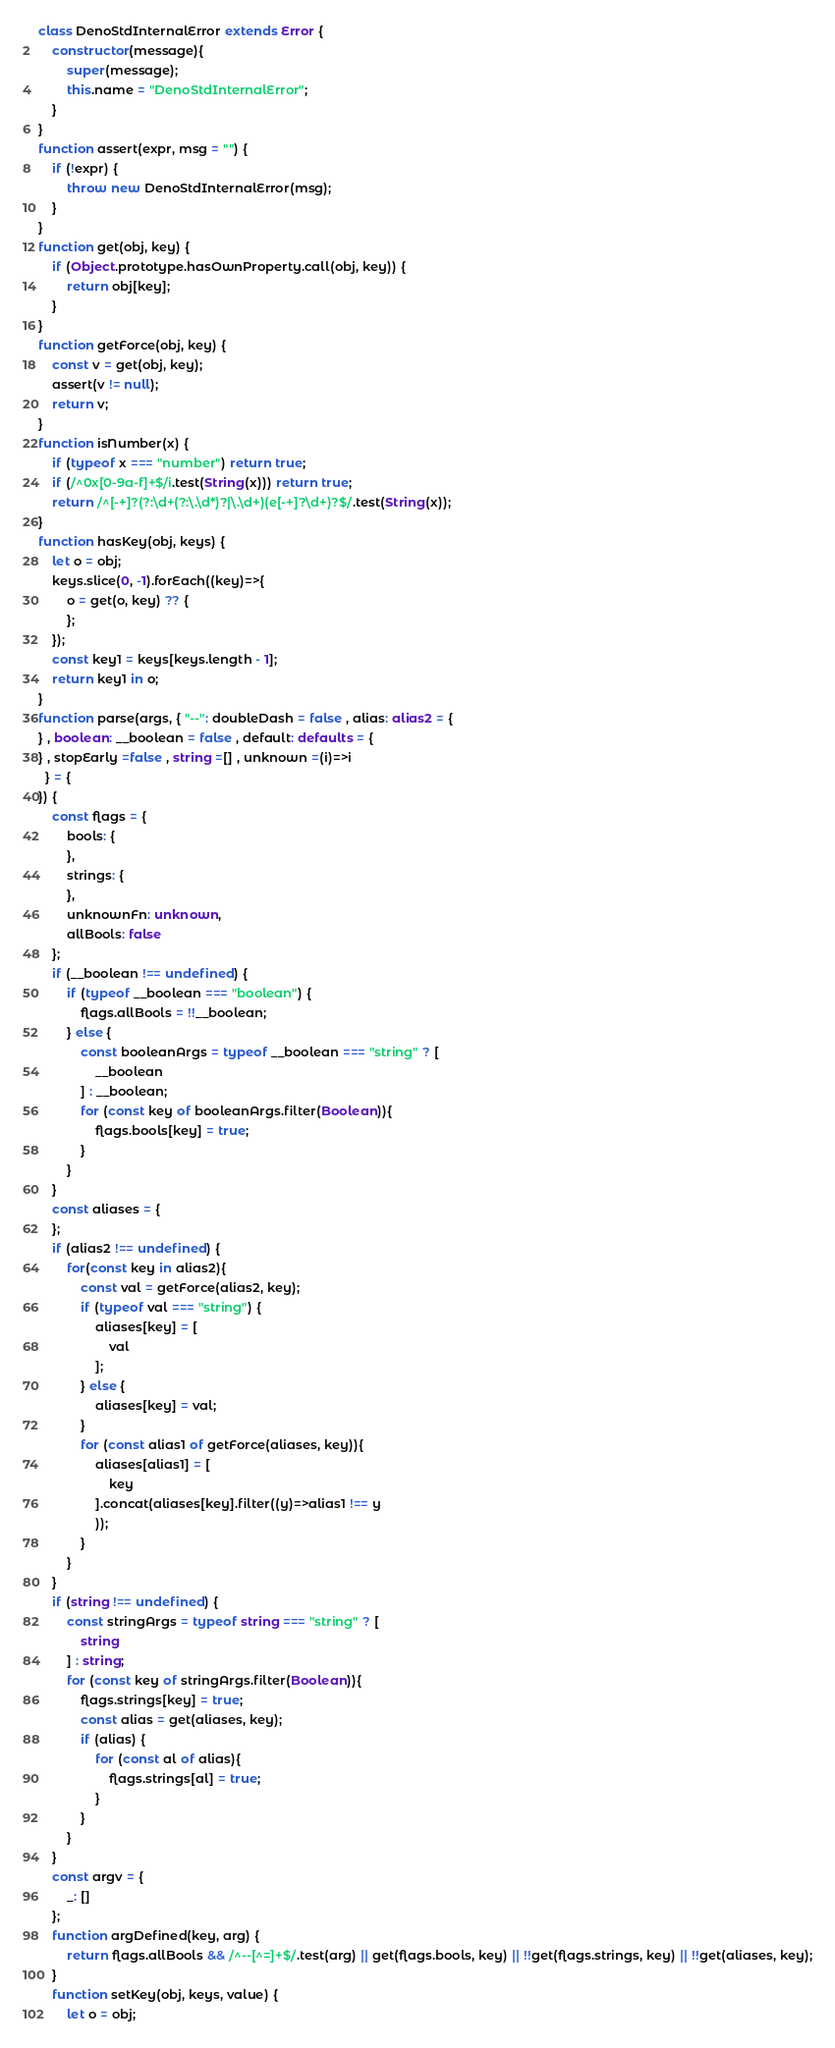Convert code to text. <code><loc_0><loc_0><loc_500><loc_500><_TypeScript_>class DenoStdInternalError extends Error {
    constructor(message){
        super(message);
        this.name = "DenoStdInternalError";
    }
}
function assert(expr, msg = "") {
    if (!expr) {
        throw new DenoStdInternalError(msg);
    }
}
function get(obj, key) {
    if (Object.prototype.hasOwnProperty.call(obj, key)) {
        return obj[key];
    }
}
function getForce(obj, key) {
    const v = get(obj, key);
    assert(v != null);
    return v;
}
function isNumber(x) {
    if (typeof x === "number") return true;
    if (/^0x[0-9a-f]+$/i.test(String(x))) return true;
    return /^[-+]?(?:\d+(?:\.\d*)?|\.\d+)(e[-+]?\d+)?$/.test(String(x));
}
function hasKey(obj, keys) {
    let o = obj;
    keys.slice(0, -1).forEach((key)=>{
        o = get(o, key) ?? {
        };
    });
    const key1 = keys[keys.length - 1];
    return key1 in o;
}
function parse(args, { "--": doubleDash = false , alias: alias2 = {
} , boolean: __boolean = false , default: defaults = {
} , stopEarly =false , string =[] , unknown =(i)=>i
  } = {
}) {
    const flags = {
        bools: {
        },
        strings: {
        },
        unknownFn: unknown,
        allBools: false
    };
    if (__boolean !== undefined) {
        if (typeof __boolean === "boolean") {
            flags.allBools = !!__boolean;
        } else {
            const booleanArgs = typeof __boolean === "string" ? [
                __boolean
            ] : __boolean;
            for (const key of booleanArgs.filter(Boolean)){
                flags.bools[key] = true;
            }
        }
    }
    const aliases = {
    };
    if (alias2 !== undefined) {
        for(const key in alias2){
            const val = getForce(alias2, key);
            if (typeof val === "string") {
                aliases[key] = [
                    val
                ];
            } else {
                aliases[key] = val;
            }
            for (const alias1 of getForce(aliases, key)){
                aliases[alias1] = [
                    key
                ].concat(aliases[key].filter((y)=>alias1 !== y
                ));
            }
        }
    }
    if (string !== undefined) {
        const stringArgs = typeof string === "string" ? [
            string
        ] : string;
        for (const key of stringArgs.filter(Boolean)){
            flags.strings[key] = true;
            const alias = get(aliases, key);
            if (alias) {
                for (const al of alias){
                    flags.strings[al] = true;
                }
            }
        }
    }
    const argv = {
        _: []
    };
    function argDefined(key, arg) {
        return flags.allBools && /^--[^=]+$/.test(arg) || get(flags.bools, key) || !!get(flags.strings, key) || !!get(aliases, key);
    }
    function setKey(obj, keys, value) {
        let o = obj;</code> 